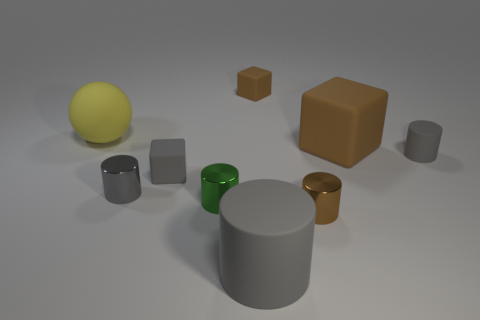Subtract all gray cylinders. How many were subtracted if there are1gray cylinders left? 2 Add 1 green blocks. How many objects exist? 10 Subtract all tiny brown cylinders. How many cylinders are left? 4 Subtract all cubes. How many objects are left? 6 Subtract all gray cubes. How many cubes are left? 2 Subtract 3 cylinders. How many cylinders are left? 2 Subtract all purple cylinders. Subtract all purple spheres. How many cylinders are left? 5 Subtract all brown cylinders. How many brown cubes are left? 2 Subtract all metallic things. Subtract all rubber objects. How many objects are left? 0 Add 9 yellow matte spheres. How many yellow matte spheres are left? 10 